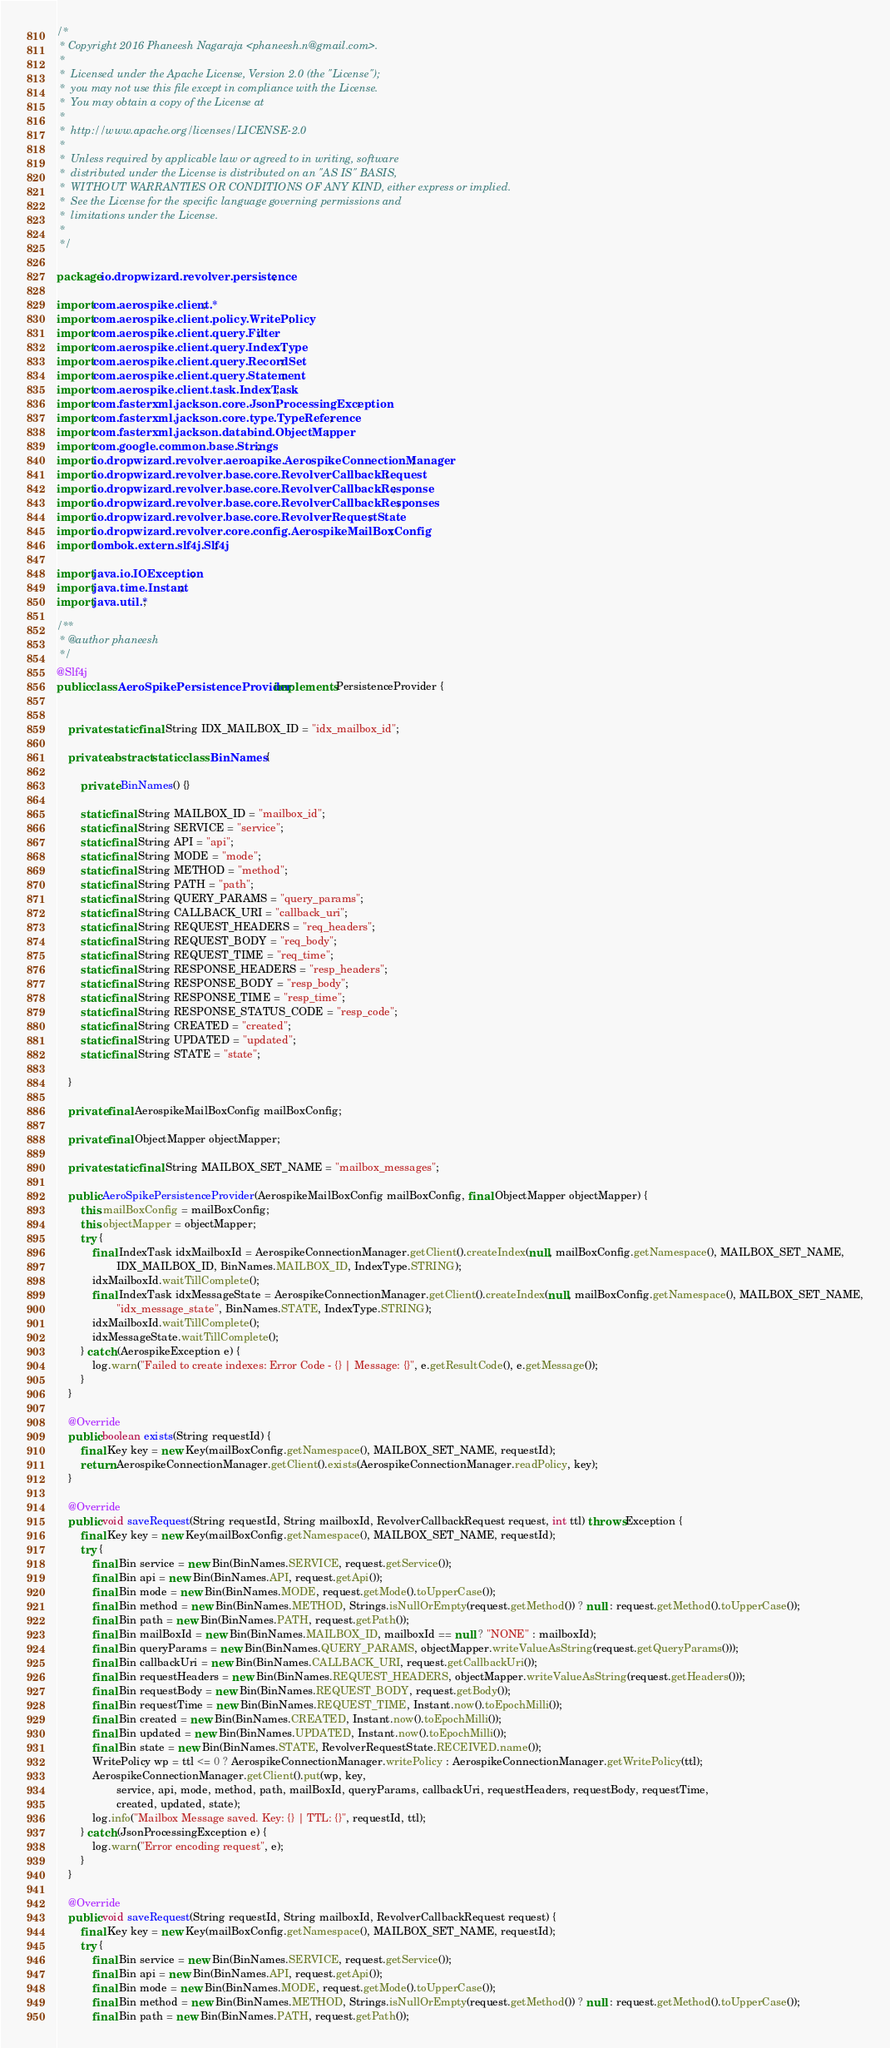Convert code to text. <code><loc_0><loc_0><loc_500><loc_500><_Java_>/*
 * Copyright 2016 Phaneesh Nagaraja <phaneesh.n@gmail.com>.
 *
 *  Licensed under the Apache License, Version 2.0 (the "License");
 *  you may not use this file except in compliance with the License.
 *  You may obtain a copy of the License at
 *
 *  http://www.apache.org/licenses/LICENSE-2.0
 *
 *  Unless required by applicable law or agreed to in writing, software
 *  distributed under the License is distributed on an "AS IS" BASIS,
 *  WITHOUT WARRANTIES OR CONDITIONS OF ANY KIND, either express or implied.
 *  See the License for the specific language governing permissions and
 *  limitations under the License.
 *
 */

package io.dropwizard.revolver.persistence;

import com.aerospike.client.*;
import com.aerospike.client.policy.WritePolicy;
import com.aerospike.client.query.Filter;
import com.aerospike.client.query.IndexType;
import com.aerospike.client.query.RecordSet;
import com.aerospike.client.query.Statement;
import com.aerospike.client.task.IndexTask;
import com.fasterxml.jackson.core.JsonProcessingException;
import com.fasterxml.jackson.core.type.TypeReference;
import com.fasterxml.jackson.databind.ObjectMapper;
import com.google.common.base.Strings;
import io.dropwizard.revolver.aeroapike.AerospikeConnectionManager;
import io.dropwizard.revolver.base.core.RevolverCallbackRequest;
import io.dropwizard.revolver.base.core.RevolverCallbackResponse;
import io.dropwizard.revolver.base.core.RevolverCallbackResponses;
import io.dropwizard.revolver.base.core.RevolverRequestState;
import io.dropwizard.revolver.core.config.AerospikeMailBoxConfig;
import lombok.extern.slf4j.Slf4j;

import java.io.IOException;
import java.time.Instant;
import java.util.*;

/**
 * @author phaneesh
 */
@Slf4j
public class AeroSpikePersistenceProvider implements PersistenceProvider {


    private static final String IDX_MAILBOX_ID = "idx_mailbox_id";

    private abstract static class BinNames {

        private BinNames() {}

        static final String MAILBOX_ID = "mailbox_id";
        static final String SERVICE = "service";
        static final String API = "api";
        static final String MODE = "mode";
        static final String METHOD = "method";
        static final String PATH = "path";
        static final String QUERY_PARAMS = "query_params";
        static final String CALLBACK_URI = "callback_uri";
        static final String REQUEST_HEADERS = "req_headers";
        static final String REQUEST_BODY = "req_body";
        static final String REQUEST_TIME = "req_time";
        static final String RESPONSE_HEADERS = "resp_headers";
        static final String RESPONSE_BODY = "resp_body";
        static final String RESPONSE_TIME = "resp_time";
        static final String RESPONSE_STATUS_CODE = "resp_code";
        static final String CREATED = "created";
        static final String UPDATED = "updated";
        static final String STATE = "state";

    }

    private final AerospikeMailBoxConfig mailBoxConfig;

    private final ObjectMapper objectMapper;

    private static final String MAILBOX_SET_NAME = "mailbox_messages";

    public AeroSpikePersistenceProvider(AerospikeMailBoxConfig mailBoxConfig, final ObjectMapper objectMapper) {
        this.mailBoxConfig = mailBoxConfig;
        this.objectMapper = objectMapper;
        try {
            final IndexTask idxMailboxId = AerospikeConnectionManager.getClient().createIndex(null, mailBoxConfig.getNamespace(), MAILBOX_SET_NAME,
                    IDX_MAILBOX_ID, BinNames.MAILBOX_ID, IndexType.STRING);
            idxMailboxId.waitTillComplete();
            final IndexTask idxMessageState = AerospikeConnectionManager.getClient().createIndex(null, mailBoxConfig.getNamespace(), MAILBOX_SET_NAME,
                    "idx_message_state", BinNames.STATE, IndexType.STRING);
            idxMailboxId.waitTillComplete();
            idxMessageState.waitTillComplete();
        } catch (AerospikeException e) {
            log.warn("Failed to create indexes: Error Code - {} | Message: {}", e.getResultCode(), e.getMessage());
        }
    }

    @Override
    public boolean exists(String requestId) {
        final Key key = new Key(mailBoxConfig.getNamespace(), MAILBOX_SET_NAME, requestId);
        return AerospikeConnectionManager.getClient().exists(AerospikeConnectionManager.readPolicy, key);
    }

    @Override
    public void saveRequest(String requestId, String mailboxId, RevolverCallbackRequest request, int ttl) throws Exception {
        final Key key = new Key(mailBoxConfig.getNamespace(), MAILBOX_SET_NAME, requestId);
        try {
            final Bin service = new Bin(BinNames.SERVICE, request.getService());
            final Bin api = new Bin(BinNames.API, request.getApi());
            final Bin mode = new Bin(BinNames.MODE, request.getMode().toUpperCase());
            final Bin method = new Bin(BinNames.METHOD, Strings.isNullOrEmpty(request.getMethod()) ? null : request.getMethod().toUpperCase());
            final Bin path = new Bin(BinNames.PATH, request.getPath());
            final Bin mailBoxId = new Bin(BinNames.MAILBOX_ID, mailboxId == null ? "NONE" : mailboxId);
            final Bin queryParams = new Bin(BinNames.QUERY_PARAMS, objectMapper.writeValueAsString(request.getQueryParams()));
            final Bin callbackUri = new Bin(BinNames.CALLBACK_URI, request.getCallbackUri());
            final Bin requestHeaders = new Bin(BinNames.REQUEST_HEADERS, objectMapper.writeValueAsString(request.getHeaders()));
            final Bin requestBody = new Bin(BinNames.REQUEST_BODY, request.getBody());
            final Bin requestTime = new Bin(BinNames.REQUEST_TIME, Instant.now().toEpochMilli());
            final Bin created = new Bin(BinNames.CREATED, Instant.now().toEpochMilli());
            final Bin updated = new Bin(BinNames.UPDATED, Instant.now().toEpochMilli());
            final Bin state = new Bin(BinNames.STATE, RevolverRequestState.RECEIVED.name());
            WritePolicy wp = ttl <= 0 ? AerospikeConnectionManager.writePolicy : AerospikeConnectionManager.getWritePolicy(ttl);
            AerospikeConnectionManager.getClient().put(wp, key,
                    service, api, mode, method, path, mailBoxId, queryParams, callbackUri, requestHeaders, requestBody, requestTime,
                    created, updated, state);
            log.info("Mailbox Message saved. Key: {} | TTL: {}", requestId, ttl);
        } catch (JsonProcessingException e) {
            log.warn("Error encoding request", e);
        }
    }

    @Override
    public void saveRequest(String requestId, String mailboxId, RevolverCallbackRequest request) {
        final Key key = new Key(mailBoxConfig.getNamespace(), MAILBOX_SET_NAME, requestId);
        try {
            final Bin service = new Bin(BinNames.SERVICE, request.getService());
            final Bin api = new Bin(BinNames.API, request.getApi());
            final Bin mode = new Bin(BinNames.MODE, request.getMode().toUpperCase());
            final Bin method = new Bin(BinNames.METHOD, Strings.isNullOrEmpty(request.getMethod()) ? null : request.getMethod().toUpperCase());
            final Bin path = new Bin(BinNames.PATH, request.getPath());</code> 